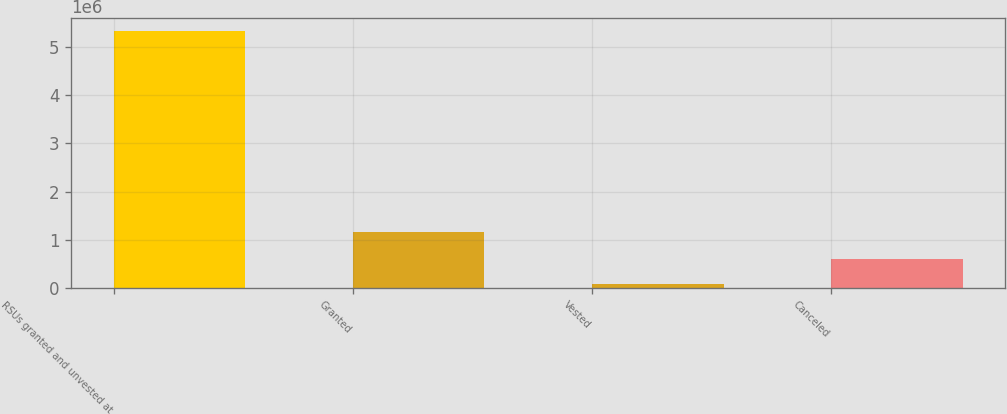Convert chart. <chart><loc_0><loc_0><loc_500><loc_500><bar_chart><fcel>RSUs granted and unvested at<fcel>Granted<fcel>Vested<fcel>Canceled<nl><fcel>5.33044e+06<fcel>1.15495e+06<fcel>81500<fcel>606394<nl></chart> 